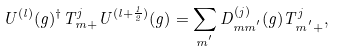<formula> <loc_0><loc_0><loc_500><loc_500>U ^ { ( l ) } ( g ) ^ { \dagger } T _ { m + } ^ { j } U ^ { ( l + \frac { 1 } { 2 } ) } ( g ) = \sum _ { m ^ { ^ { \prime } } } D _ { m m ^ { ^ { \prime } } } ^ { ( j ) } ( g ) T _ { m ^ { ^ { \prime } } + } ^ { j } ,</formula> 